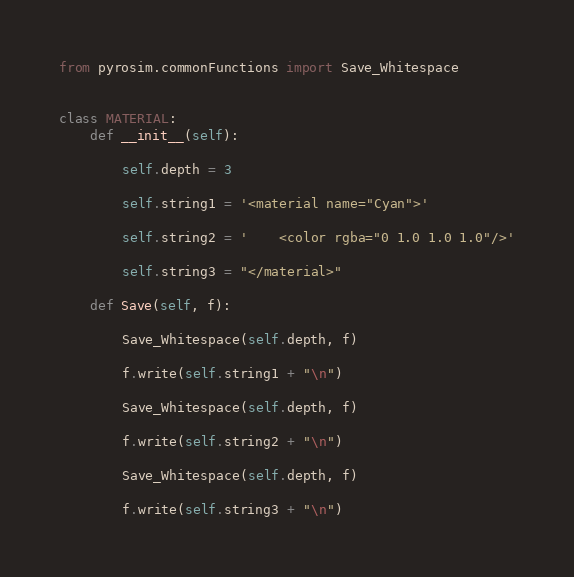<code> <loc_0><loc_0><loc_500><loc_500><_Python_>from pyrosim.commonFunctions import Save_Whitespace


class MATERIAL:
    def __init__(self):

        self.depth = 3

        self.string1 = '<material name="Cyan">'

        self.string2 = '    <color rgba="0 1.0 1.0 1.0"/>'

        self.string3 = "</material>"

    def Save(self, f):

        Save_Whitespace(self.depth, f)

        f.write(self.string1 + "\n")

        Save_Whitespace(self.depth, f)

        f.write(self.string2 + "\n")

        Save_Whitespace(self.depth, f)

        f.write(self.string3 + "\n")
</code> 